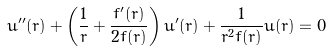Convert formula to latex. <formula><loc_0><loc_0><loc_500><loc_500>u ^ { \prime \prime } ( r ) + \left ( \frac { 1 } { r } + \frac { f ^ { \prime } ( r ) } { 2 f ( r ) } \right ) u ^ { \prime } ( r ) + \frac { 1 } { r ^ { 2 } f ( r ) } u ( r ) = 0</formula> 